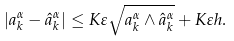Convert formula to latex. <formula><loc_0><loc_0><loc_500><loc_500>| a ^ { \alpha } _ { k } - \hat { a } ^ { \alpha } _ { k } | \leq K \varepsilon \sqrt { a ^ { \alpha } _ { k } \wedge \hat { a } ^ { \alpha } _ { k } } + K \varepsilon h .</formula> 